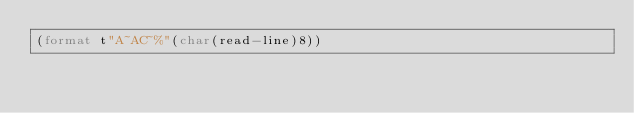Convert code to text. <code><loc_0><loc_0><loc_500><loc_500><_Lisp_>(format t"A~AC~%"(char(read-line)8))</code> 